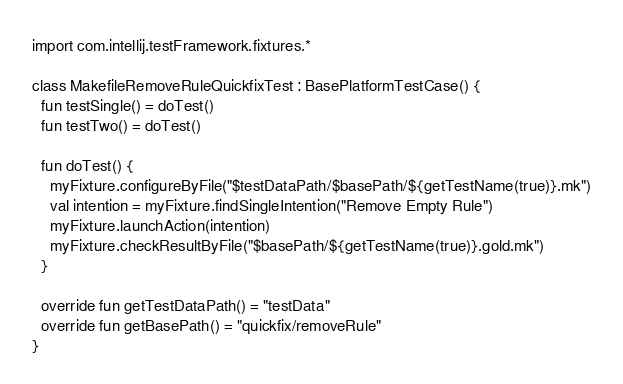<code> <loc_0><loc_0><loc_500><loc_500><_Kotlin_>import com.intellij.testFramework.fixtures.*

class MakefileRemoveRuleQuickfixTest : BasePlatformTestCase() {
  fun testSingle() = doTest()
  fun testTwo() = doTest()

  fun doTest() {
    myFixture.configureByFile("$testDataPath/$basePath/${getTestName(true)}.mk")
    val intention = myFixture.findSingleIntention("Remove Empty Rule")
    myFixture.launchAction(intention)
    myFixture.checkResultByFile("$basePath/${getTestName(true)}.gold.mk")
  }

  override fun getTestDataPath() = "testData"
  override fun getBasePath() = "quickfix/removeRule"
}</code> 